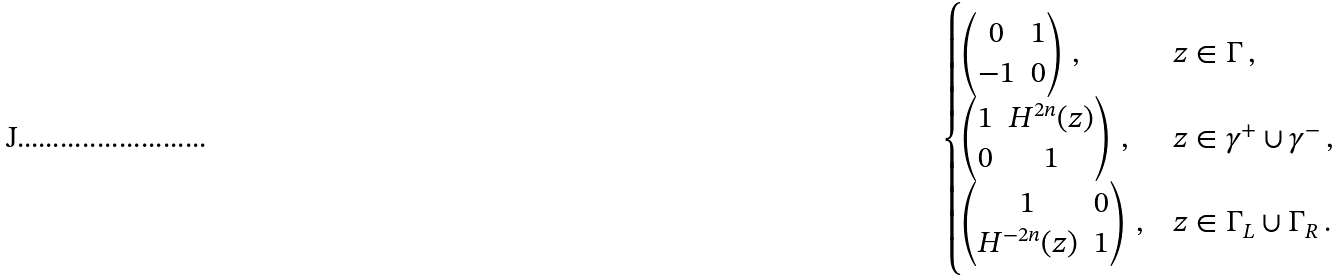Convert formula to latex. <formula><loc_0><loc_0><loc_500><loc_500>\begin{cases} \begin{pmatrix} 0 & 1 \\ - 1 & 0 \end{pmatrix} \, , & z \in \Gamma \, , \\ \begin{pmatrix} 1 & H ^ { 2 n } ( z ) \\ 0 & 1 \end{pmatrix} \, , & z \in \gamma ^ { + } \cup \gamma ^ { - } \, , \\ \begin{pmatrix} 1 & 0 \\ H ^ { - 2 n } ( z ) & 1 \end{pmatrix} \, , & z \in \Gamma _ { L } \cup \Gamma _ { R } \, . \end{cases}</formula> 